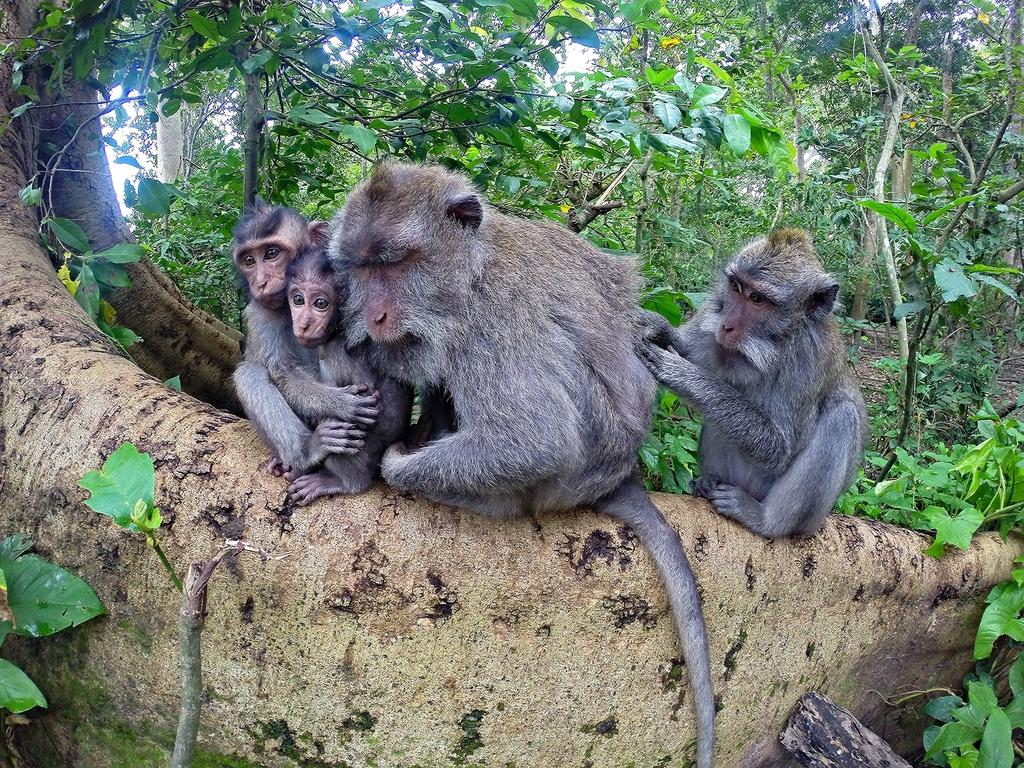How many monkeys are present in the image? There are four monkeys in the image. What can be seen in the background of the image? Trees and the ground are visible in the background of the image. What type of polish is being applied to the stone in the image? There is no stone or polish present in the image; it features four monkeys and a background with trees and the ground. 